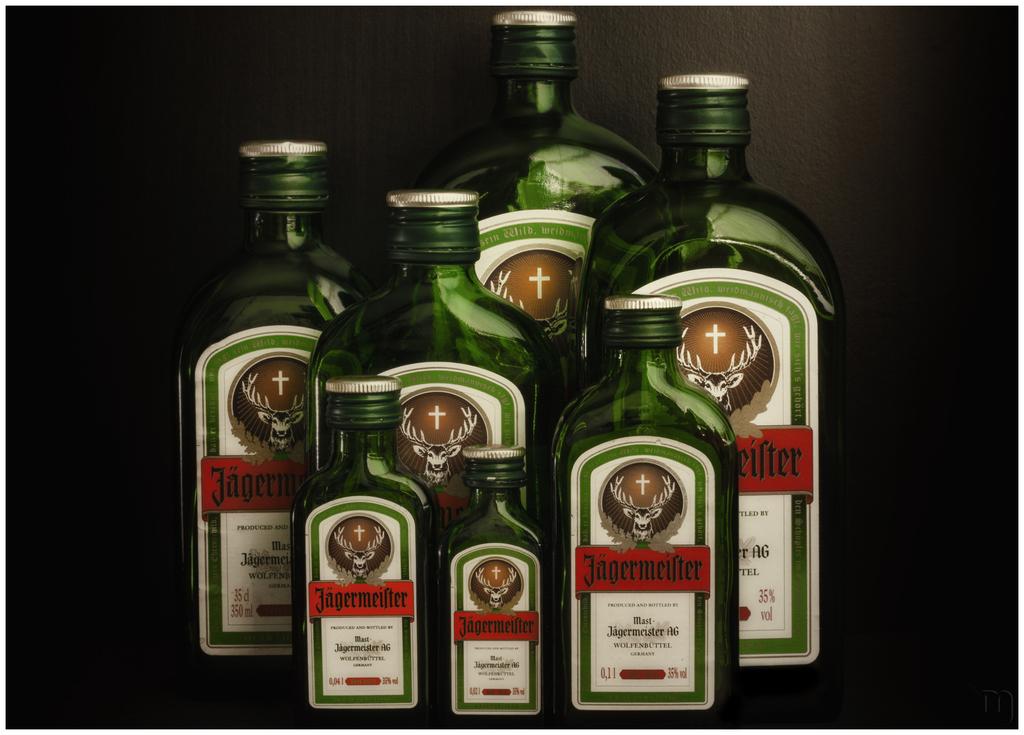What is the brand name of the above drink?
Your answer should be very brief. Jagermeister. 